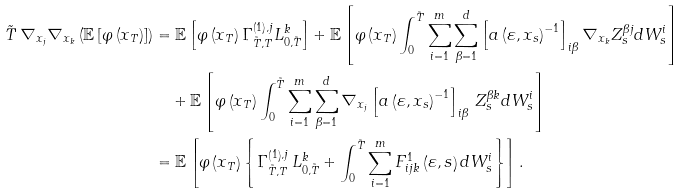<formula> <loc_0><loc_0><loc_500><loc_500>\tilde { T } \, \nabla _ { x _ { j } } \nabla _ { x _ { k } } \left ( \mathbb { E } \left [ \varphi \left ( x _ { T } \right ) \right ] \right ) & = \mathbb { E } \left [ \varphi \left ( x _ { T } \right ) \Gamma _ { \tilde { T } , T } ^ { \left ( 1 \right ) , j } L _ { 0 , \tilde { T } } ^ { k } \right ] + \mathbb { E } \left [ \varphi \left ( x _ { T } \right ) \int _ { 0 } ^ { \tilde { T } } \sum _ { i = 1 } ^ { m } \sum _ { \beta = 1 } ^ { d } \left [ a \left ( \varepsilon , x _ { s } \right ) ^ { - 1 } \right ] _ { i \beta } \nabla _ { x _ { k } } Z _ { s } ^ { \beta j } d W _ { s } ^ { i } \right ] \\ & \quad + \mathbb { E } \left [ \varphi \left ( x _ { T } \right ) \int _ { 0 } ^ { \tilde { T } } \sum _ { i = 1 } ^ { m } \sum _ { \beta = 1 } ^ { d } \nabla _ { x _ { j } } \left [ a \left ( \varepsilon , x _ { s } \right ) ^ { - 1 } \right ] _ { i \beta } \, Z _ { s } ^ { \beta k } d W _ { s } ^ { i } \right ] \\ & = \mathbb { E } \left [ \varphi \left ( x _ { T } \right ) \left \{ \Gamma _ { \tilde { T } , T } ^ { \left ( 1 \right ) , j } \, L _ { 0 , \tilde { T } } ^ { k } + \int _ { 0 } ^ { \tilde { T } } \sum _ { i = 1 } ^ { m } F _ { i j k } ^ { 1 } \left ( \varepsilon , s \right ) d W _ { s } ^ { i } \right \} \right ] .</formula> 